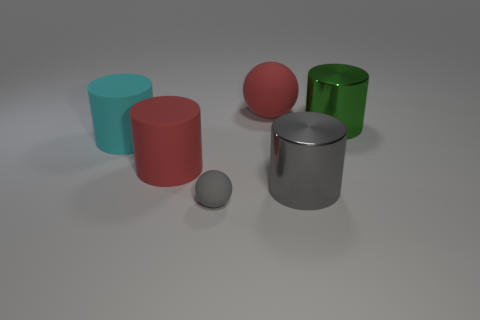Subtract all green metal cylinders. How many cylinders are left? 3 Add 3 big red rubber balls. How many objects exist? 9 Subtract all red cylinders. How many cylinders are left? 3 Subtract 1 balls. How many balls are left? 1 Subtract all cylinders. How many objects are left? 2 Add 6 gray spheres. How many gray spheres are left? 7 Add 3 tiny purple shiny things. How many tiny purple shiny things exist? 3 Subtract 1 red cylinders. How many objects are left? 5 Subtract all cyan cylinders. Subtract all green cubes. How many cylinders are left? 3 Subtract all brown cylinders. How many cyan spheres are left? 0 